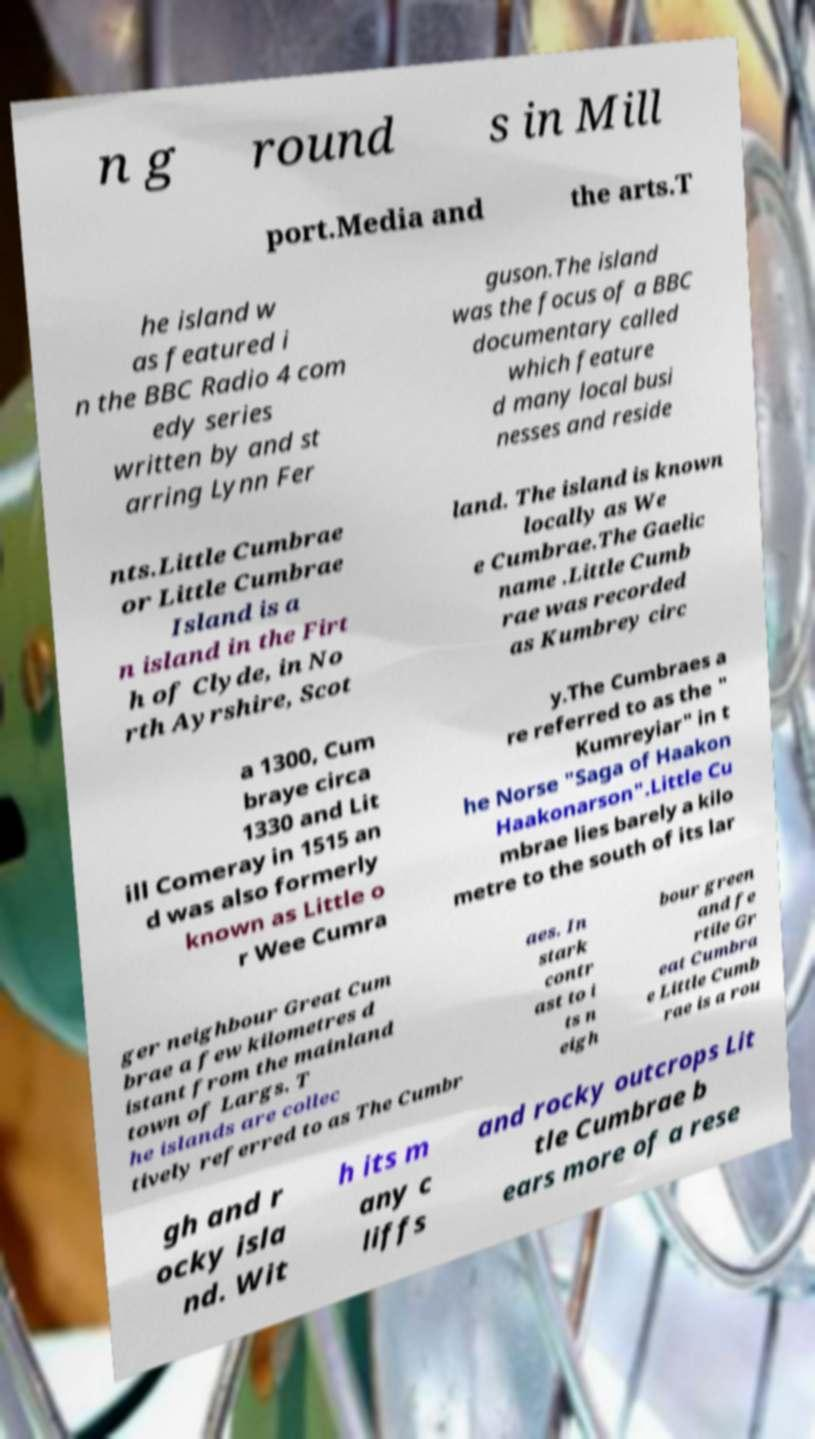Could you assist in decoding the text presented in this image and type it out clearly? n g round s in Mill port.Media and the arts.T he island w as featured i n the BBC Radio 4 com edy series written by and st arring Lynn Fer guson.The island was the focus of a BBC documentary called which feature d many local busi nesses and reside nts.Little Cumbrae or Little Cumbrae Island is a n island in the Firt h of Clyde, in No rth Ayrshire, Scot land. The island is known locally as We e Cumbrae.The Gaelic name .Little Cumb rae was recorded as Kumbrey circ a 1300, Cum braye circa 1330 and Lit ill Comeray in 1515 an d was also formerly known as Little o r Wee Cumra y.The Cumbraes a re referred to as the " Kumreyiar" in t he Norse "Saga of Haakon Haakonarson".Little Cu mbrae lies barely a kilo metre to the south of its lar ger neighbour Great Cum brae a few kilometres d istant from the mainland town of Largs. T he islands are collec tively referred to as The Cumbr aes. In stark contr ast to i ts n eigh bour green and fe rtile Gr eat Cumbra e Little Cumb rae is a rou gh and r ocky isla nd. Wit h its m any c liffs and rocky outcrops Lit tle Cumbrae b ears more of a rese 